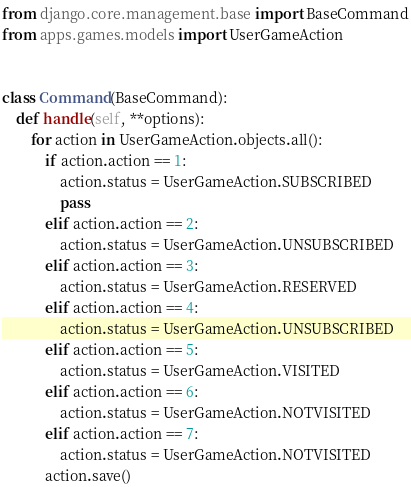<code> <loc_0><loc_0><loc_500><loc_500><_Python_>from django.core.management.base import BaseCommand
from apps.games.models import UserGameAction


class Command(BaseCommand):
    def handle(self, **options):
        for action in UserGameAction.objects.all():
            if action.action == 1:
                action.status = UserGameAction.SUBSCRIBED
                pass
            elif action.action == 2:
                action.status = UserGameAction.UNSUBSCRIBED
            elif action.action == 3:
                action.status = UserGameAction.RESERVED
            elif action.action == 4:
                action.status = UserGameAction.UNSUBSCRIBED
            elif action.action == 5:
                action.status = UserGameAction.VISITED
            elif action.action == 6:
                action.status = UserGameAction.NOTVISITED
            elif action.action == 7:
                action.status = UserGameAction.NOTVISITED
            action.save()
</code> 